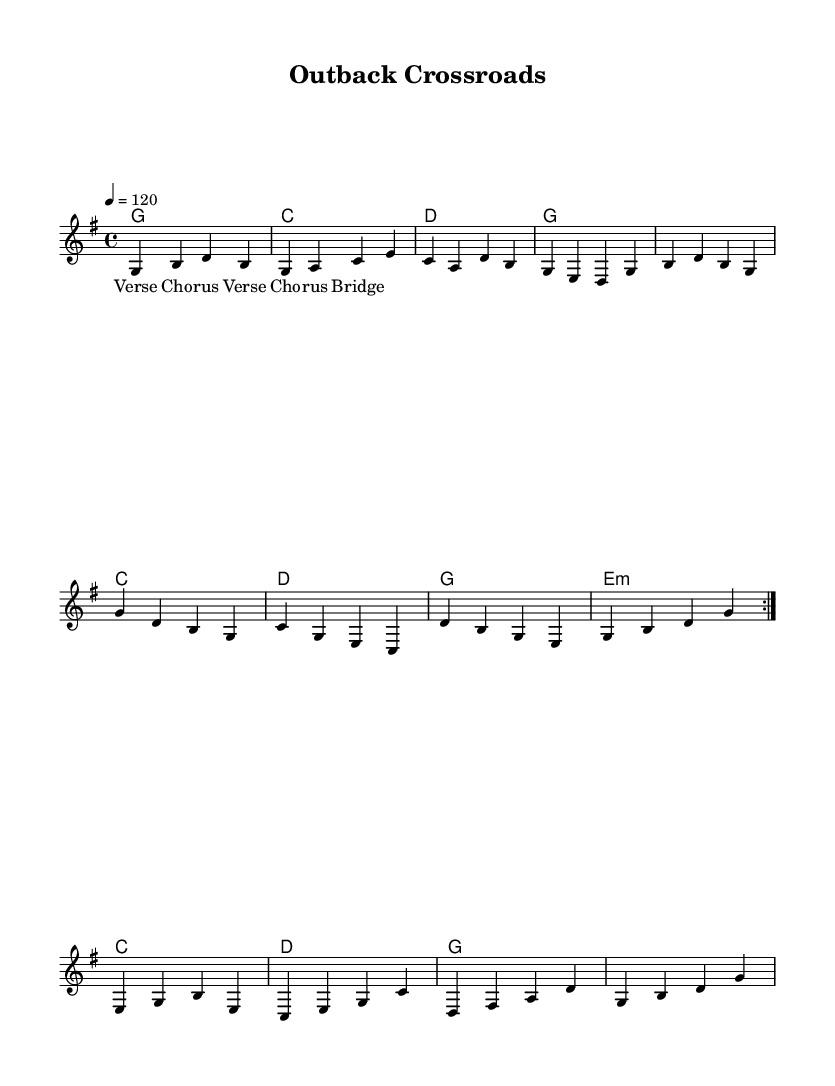What is the key signature of this music? The key signature is G major, which has one sharp (F#). This is indicated at the beginning of the music sheet.
Answer: G major What is the time signature of this music? The time signature is 4/4, which means there are four beats in each measure and a quarter note gets one beat. This is noted at the start of the music.
Answer: 4/4 What is the tempo marking for this piece? The tempo marking is "4 = 120", which indicates that there are 120 quarter-note beats per minute. This is found at the beginning of the score.
Answer: 120 How many measures are repeated in the melody? The melody contains a section that is repeated twice, indicated by the "repeat volta 2" marking. This specifies a repeated phrase in the music.
Answer: 2 What is the last chord in the harmonies section? The last chord in the harmonies is G major, as indicated in the final measure of the chord progression. This is established in the harmonies part.
Answer: G What type of song structure is used in this piece? The song structure follows a verse-chorus format with repeated sections, indicated by the lyrical layout labeled as "Verse 1 Chorus," "Verse 2 Chorus," and "Bridge." This outlines the form of the song.
Answer: Verse-Chorus 